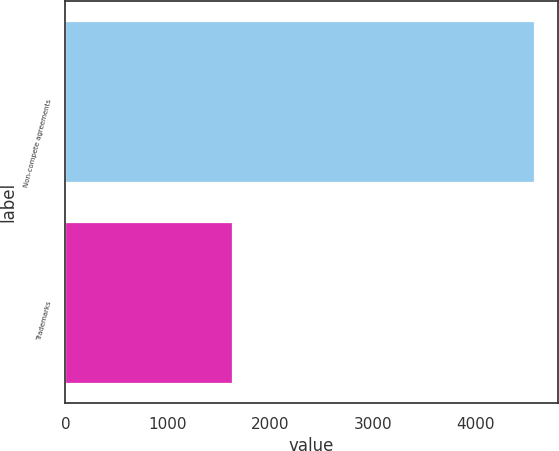<chart> <loc_0><loc_0><loc_500><loc_500><bar_chart><fcel>Non-compete agreements<fcel>Trademarks<nl><fcel>4574<fcel>1623<nl></chart> 